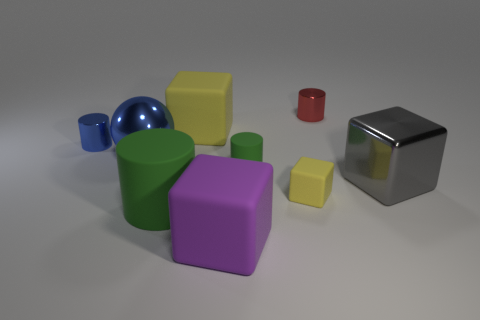Add 1 yellow matte things. How many objects exist? 10 Subtract all blocks. How many objects are left? 5 Add 4 large cylinders. How many large cylinders are left? 5 Add 1 large red balls. How many large red balls exist? 1 Subtract 2 yellow blocks. How many objects are left? 7 Subtract all big cyan cylinders. Subtract all small red shiny cylinders. How many objects are left? 8 